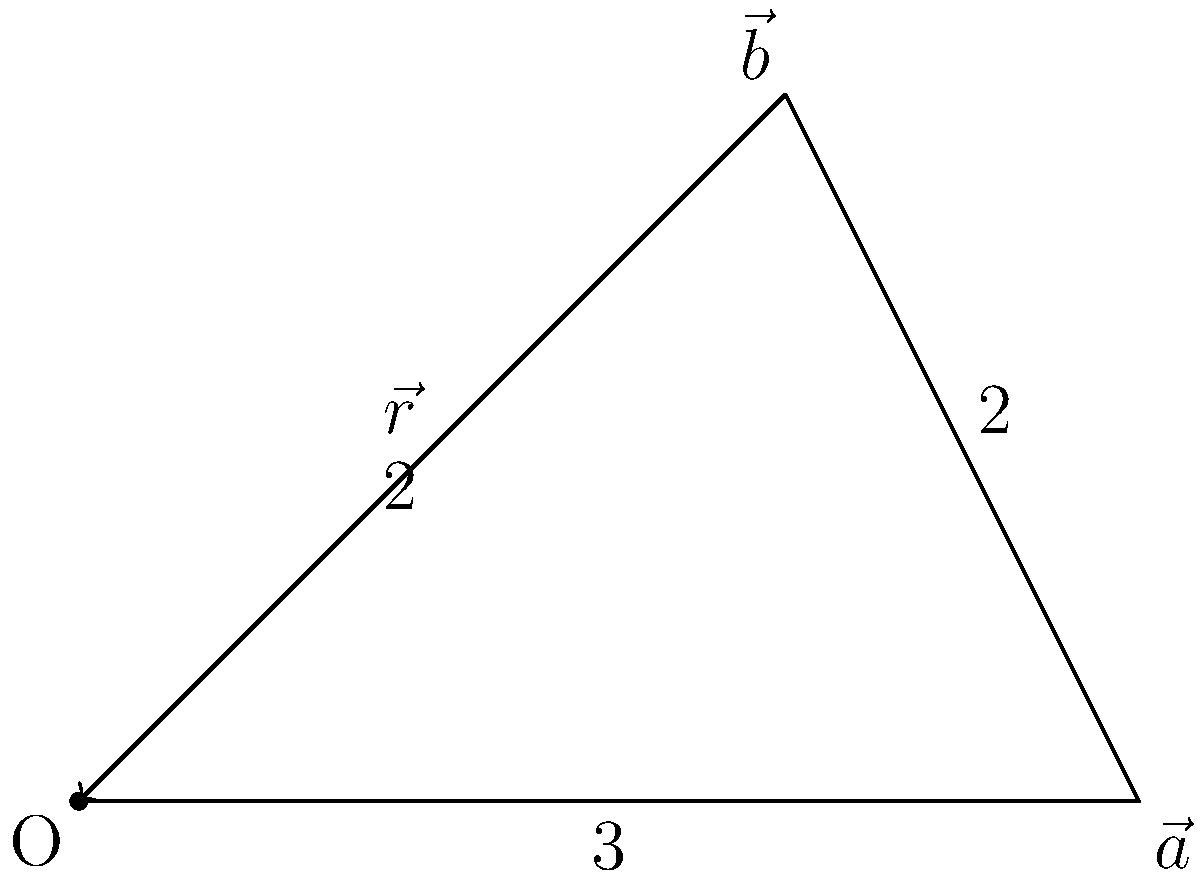In the vector diagram, $\vec{a}$ and $\vec{b}$ are two vectors with magnitudes 3 and 2 units respectively. The angle between them is 90°. Calculate the magnitude of the resultant vector $\vec{r}$. To find the magnitude of the resultant vector $\vec{r}$, we can use the Pythagorean theorem since the two vectors are perpendicular to each other. Here's the step-by-step solution:

1. Identify the given information:
   - $|\vec{a}| = 3$ units
   - $|\vec{b}| = 2$ units
   - The angle between $\vec{a}$ and $\vec{b}$ is 90°

2. Apply the Pythagorean theorem:
   $|\vec{r}|^2 = |\vec{a}|^2 + |\vec{b}|^2$

3. Substitute the known values:
   $|\vec{r}|^2 = 3^2 + 2^2$

4. Calculate the squares:
   $|\vec{r}|^2 = 9 + 4 = 13$

5. Take the square root of both sides:
   $|\vec{r}| = \sqrt{13}$

Therefore, the magnitude of the resultant vector $\vec{r}$ is $\sqrt{13}$ units.
Answer: $\sqrt{13}$ units 